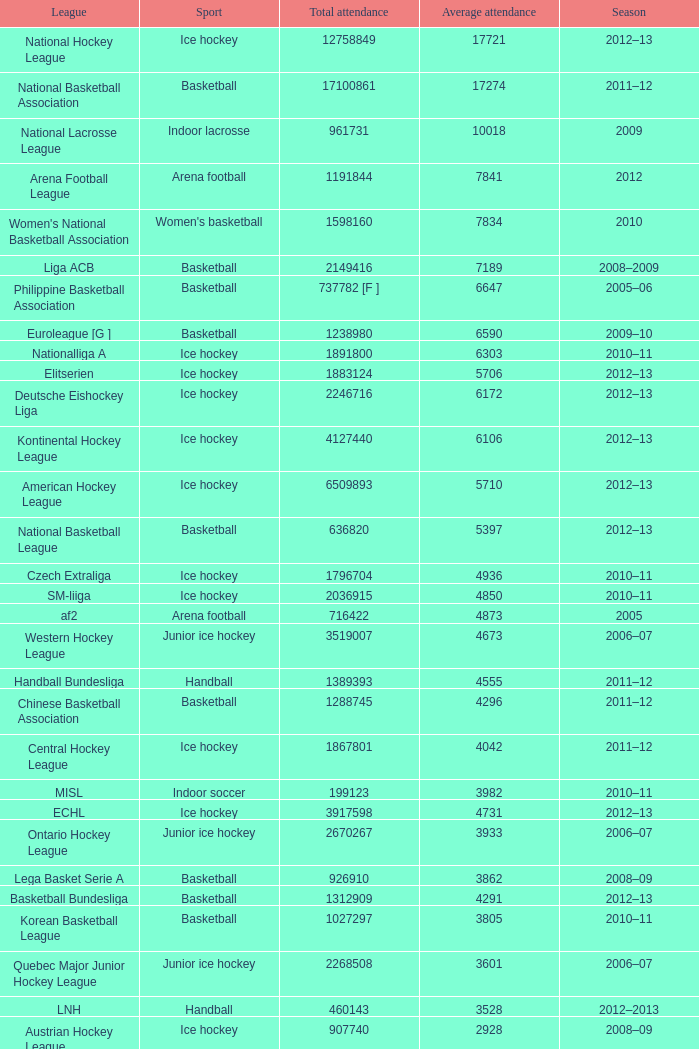What was the highest average attendance in the 2009 season? 10018.0. 